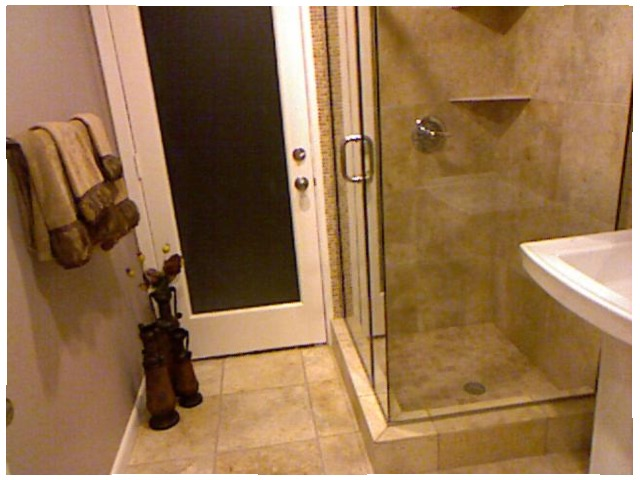<image>
Is the vase on the floor? Yes. Looking at the image, I can see the vase is positioned on top of the floor, with the floor providing support. Is there a door to the right of the shower? No. The door is not to the right of the shower. The horizontal positioning shows a different relationship. Is there a drain in the shower? Yes. The drain is contained within or inside the shower, showing a containment relationship. 